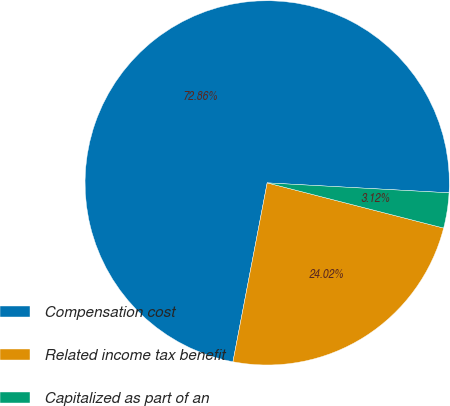<chart> <loc_0><loc_0><loc_500><loc_500><pie_chart><fcel>Compensation cost<fcel>Related income tax benefit<fcel>Capitalized as part of an<nl><fcel>72.86%<fcel>24.02%<fcel>3.12%<nl></chart> 